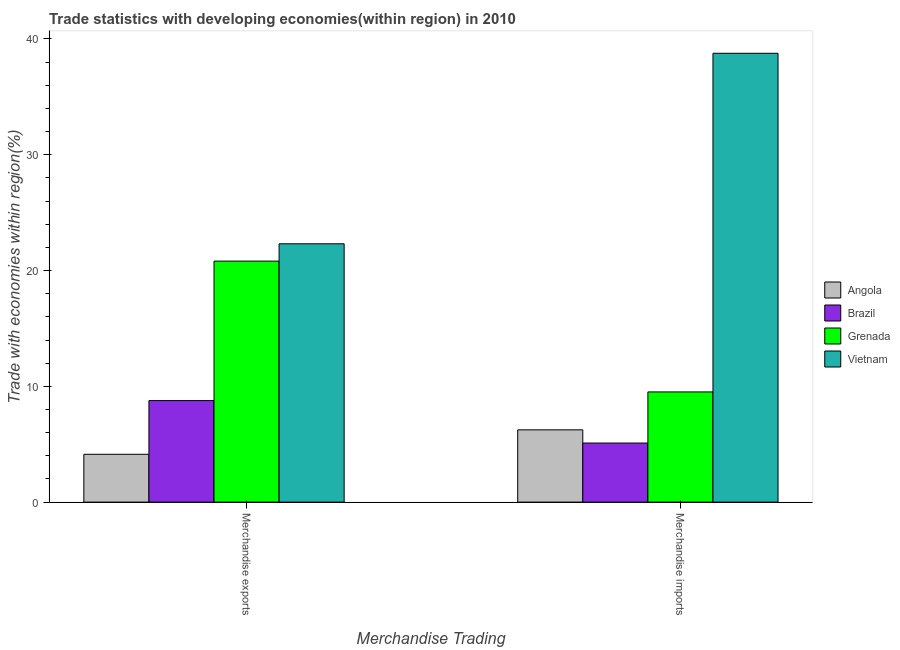How many groups of bars are there?
Ensure brevity in your answer.  2. Are the number of bars per tick equal to the number of legend labels?
Ensure brevity in your answer.  Yes. Are the number of bars on each tick of the X-axis equal?
Provide a short and direct response. Yes. What is the label of the 2nd group of bars from the left?
Provide a short and direct response. Merchandise imports. What is the merchandise imports in Angola?
Offer a terse response. 6.24. Across all countries, what is the maximum merchandise exports?
Ensure brevity in your answer.  22.31. Across all countries, what is the minimum merchandise exports?
Ensure brevity in your answer.  4.13. In which country was the merchandise exports maximum?
Make the answer very short. Vietnam. What is the total merchandise imports in the graph?
Give a very brief answer. 59.63. What is the difference between the merchandise imports in Vietnam and that in Angola?
Offer a very short reply. 32.52. What is the difference between the merchandise exports in Grenada and the merchandise imports in Angola?
Your answer should be very brief. 14.57. What is the average merchandise imports per country?
Keep it short and to the point. 14.91. What is the difference between the merchandise imports and merchandise exports in Brazil?
Provide a short and direct response. -3.67. In how many countries, is the merchandise exports greater than 10 %?
Give a very brief answer. 2. What is the ratio of the merchandise exports in Angola to that in Grenada?
Your answer should be compact. 0.2. Is the merchandise imports in Brazil less than that in Grenada?
Your response must be concise. Yes. In how many countries, is the merchandise imports greater than the average merchandise imports taken over all countries?
Give a very brief answer. 1. What does the 1st bar from the left in Merchandise imports represents?
Ensure brevity in your answer.  Angola. What does the 1st bar from the right in Merchandise imports represents?
Provide a short and direct response. Vietnam. How many bars are there?
Your response must be concise. 8. How many legend labels are there?
Give a very brief answer. 4. What is the title of the graph?
Keep it short and to the point. Trade statistics with developing economies(within region) in 2010. Does "Puerto Rico" appear as one of the legend labels in the graph?
Your answer should be very brief. No. What is the label or title of the X-axis?
Give a very brief answer. Merchandise Trading. What is the label or title of the Y-axis?
Make the answer very short. Trade with economies within region(%). What is the Trade with economies within region(%) of Angola in Merchandise exports?
Your response must be concise. 4.13. What is the Trade with economies within region(%) of Brazil in Merchandise exports?
Provide a succinct answer. 8.77. What is the Trade with economies within region(%) of Grenada in Merchandise exports?
Offer a very short reply. 20.81. What is the Trade with economies within region(%) in Vietnam in Merchandise exports?
Keep it short and to the point. 22.31. What is the Trade with economies within region(%) in Angola in Merchandise imports?
Make the answer very short. 6.24. What is the Trade with economies within region(%) of Brazil in Merchandise imports?
Provide a succinct answer. 5.1. What is the Trade with economies within region(%) in Grenada in Merchandise imports?
Offer a very short reply. 9.52. What is the Trade with economies within region(%) of Vietnam in Merchandise imports?
Keep it short and to the point. 38.76. Across all Merchandise Trading, what is the maximum Trade with economies within region(%) of Angola?
Give a very brief answer. 6.24. Across all Merchandise Trading, what is the maximum Trade with economies within region(%) of Brazil?
Your response must be concise. 8.77. Across all Merchandise Trading, what is the maximum Trade with economies within region(%) in Grenada?
Your response must be concise. 20.81. Across all Merchandise Trading, what is the maximum Trade with economies within region(%) in Vietnam?
Offer a very short reply. 38.76. Across all Merchandise Trading, what is the minimum Trade with economies within region(%) of Angola?
Provide a succinct answer. 4.13. Across all Merchandise Trading, what is the minimum Trade with economies within region(%) of Brazil?
Your answer should be compact. 5.1. Across all Merchandise Trading, what is the minimum Trade with economies within region(%) in Grenada?
Provide a short and direct response. 9.52. Across all Merchandise Trading, what is the minimum Trade with economies within region(%) of Vietnam?
Your answer should be very brief. 22.31. What is the total Trade with economies within region(%) in Angola in the graph?
Your answer should be compact. 10.37. What is the total Trade with economies within region(%) in Brazil in the graph?
Your answer should be compact. 13.87. What is the total Trade with economies within region(%) of Grenada in the graph?
Offer a very short reply. 30.33. What is the total Trade with economies within region(%) in Vietnam in the graph?
Your response must be concise. 61.07. What is the difference between the Trade with economies within region(%) of Angola in Merchandise exports and that in Merchandise imports?
Give a very brief answer. -2.11. What is the difference between the Trade with economies within region(%) of Brazil in Merchandise exports and that in Merchandise imports?
Give a very brief answer. 3.67. What is the difference between the Trade with economies within region(%) in Grenada in Merchandise exports and that in Merchandise imports?
Provide a succinct answer. 11.3. What is the difference between the Trade with economies within region(%) of Vietnam in Merchandise exports and that in Merchandise imports?
Provide a short and direct response. -16.45. What is the difference between the Trade with economies within region(%) of Angola in Merchandise exports and the Trade with economies within region(%) of Brazil in Merchandise imports?
Your answer should be compact. -0.97. What is the difference between the Trade with economies within region(%) of Angola in Merchandise exports and the Trade with economies within region(%) of Grenada in Merchandise imports?
Your response must be concise. -5.39. What is the difference between the Trade with economies within region(%) of Angola in Merchandise exports and the Trade with economies within region(%) of Vietnam in Merchandise imports?
Your response must be concise. -34.63. What is the difference between the Trade with economies within region(%) in Brazil in Merchandise exports and the Trade with economies within region(%) in Grenada in Merchandise imports?
Make the answer very short. -0.75. What is the difference between the Trade with economies within region(%) of Brazil in Merchandise exports and the Trade with economies within region(%) of Vietnam in Merchandise imports?
Keep it short and to the point. -29.99. What is the difference between the Trade with economies within region(%) of Grenada in Merchandise exports and the Trade with economies within region(%) of Vietnam in Merchandise imports?
Provide a succinct answer. -17.95. What is the average Trade with economies within region(%) in Angola per Merchandise Trading?
Offer a terse response. 5.19. What is the average Trade with economies within region(%) in Brazil per Merchandise Trading?
Provide a succinct answer. 6.94. What is the average Trade with economies within region(%) in Grenada per Merchandise Trading?
Give a very brief answer. 15.17. What is the average Trade with economies within region(%) of Vietnam per Merchandise Trading?
Provide a succinct answer. 30.54. What is the difference between the Trade with economies within region(%) of Angola and Trade with economies within region(%) of Brazil in Merchandise exports?
Your answer should be very brief. -4.64. What is the difference between the Trade with economies within region(%) of Angola and Trade with economies within region(%) of Grenada in Merchandise exports?
Provide a succinct answer. -16.68. What is the difference between the Trade with economies within region(%) of Angola and Trade with economies within region(%) of Vietnam in Merchandise exports?
Provide a short and direct response. -18.18. What is the difference between the Trade with economies within region(%) in Brazil and Trade with economies within region(%) in Grenada in Merchandise exports?
Your answer should be compact. -12.04. What is the difference between the Trade with economies within region(%) in Brazil and Trade with economies within region(%) in Vietnam in Merchandise exports?
Your answer should be compact. -13.54. What is the difference between the Trade with economies within region(%) of Grenada and Trade with economies within region(%) of Vietnam in Merchandise exports?
Make the answer very short. -1.5. What is the difference between the Trade with economies within region(%) in Angola and Trade with economies within region(%) in Brazil in Merchandise imports?
Ensure brevity in your answer.  1.14. What is the difference between the Trade with economies within region(%) of Angola and Trade with economies within region(%) of Grenada in Merchandise imports?
Provide a short and direct response. -3.27. What is the difference between the Trade with economies within region(%) of Angola and Trade with economies within region(%) of Vietnam in Merchandise imports?
Offer a very short reply. -32.52. What is the difference between the Trade with economies within region(%) in Brazil and Trade with economies within region(%) in Grenada in Merchandise imports?
Your answer should be compact. -4.41. What is the difference between the Trade with economies within region(%) of Brazil and Trade with economies within region(%) of Vietnam in Merchandise imports?
Offer a terse response. -33.66. What is the difference between the Trade with economies within region(%) of Grenada and Trade with economies within region(%) of Vietnam in Merchandise imports?
Ensure brevity in your answer.  -29.25. What is the ratio of the Trade with economies within region(%) of Angola in Merchandise exports to that in Merchandise imports?
Give a very brief answer. 0.66. What is the ratio of the Trade with economies within region(%) in Brazil in Merchandise exports to that in Merchandise imports?
Keep it short and to the point. 1.72. What is the ratio of the Trade with economies within region(%) in Grenada in Merchandise exports to that in Merchandise imports?
Provide a short and direct response. 2.19. What is the ratio of the Trade with economies within region(%) in Vietnam in Merchandise exports to that in Merchandise imports?
Offer a very short reply. 0.58. What is the difference between the highest and the second highest Trade with economies within region(%) of Angola?
Offer a terse response. 2.11. What is the difference between the highest and the second highest Trade with economies within region(%) of Brazil?
Provide a short and direct response. 3.67. What is the difference between the highest and the second highest Trade with economies within region(%) in Grenada?
Offer a very short reply. 11.3. What is the difference between the highest and the second highest Trade with economies within region(%) in Vietnam?
Ensure brevity in your answer.  16.45. What is the difference between the highest and the lowest Trade with economies within region(%) of Angola?
Keep it short and to the point. 2.11. What is the difference between the highest and the lowest Trade with economies within region(%) of Brazil?
Give a very brief answer. 3.67. What is the difference between the highest and the lowest Trade with economies within region(%) of Grenada?
Offer a terse response. 11.3. What is the difference between the highest and the lowest Trade with economies within region(%) of Vietnam?
Provide a short and direct response. 16.45. 